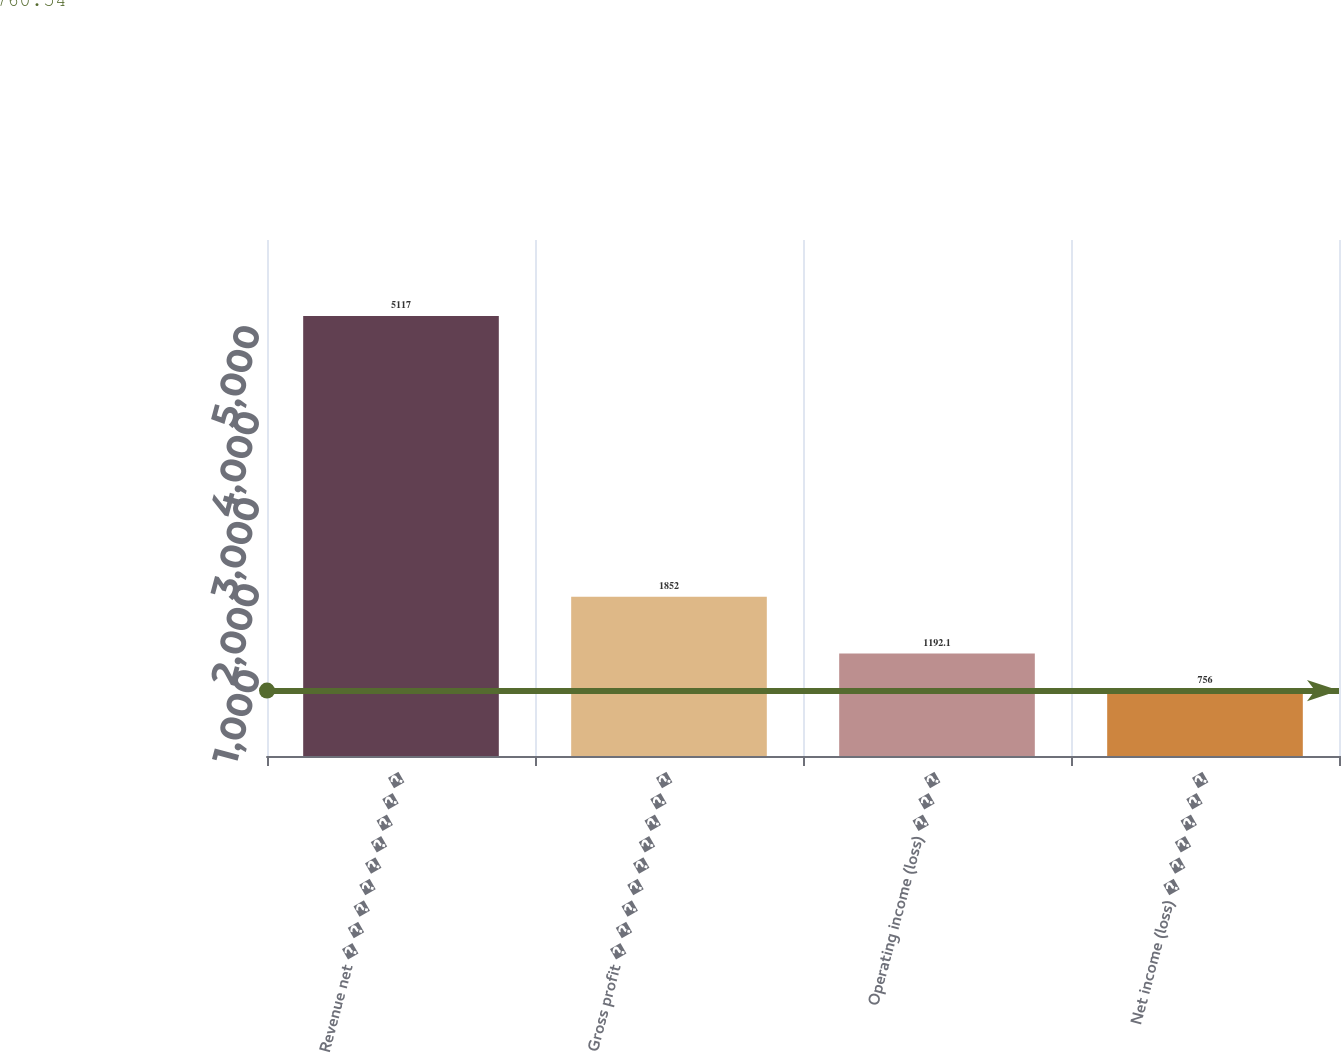<chart> <loc_0><loc_0><loc_500><loc_500><bar_chart><fcel>Revenue net � � � � � � � � �<fcel>Gross profit � � � � � � � � �<fcel>Operating income (loss) � � �<fcel>Net income (loss) � � � � � �<nl><fcel>5117<fcel>1852<fcel>1192.1<fcel>756<nl></chart> 